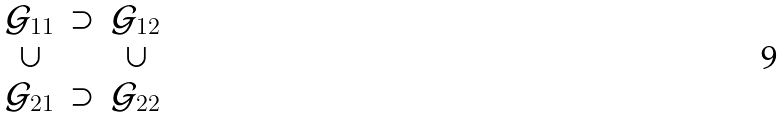<formula> <loc_0><loc_0><loc_500><loc_500>\begin{matrix} \mathcal { G } _ { 1 1 } & \supset & \mathcal { G } _ { 1 2 } \\ \cup & & \cup \\ \mathcal { G } _ { 2 1 } & \supset & \mathcal { G } _ { 2 2 } \end{matrix}</formula> 